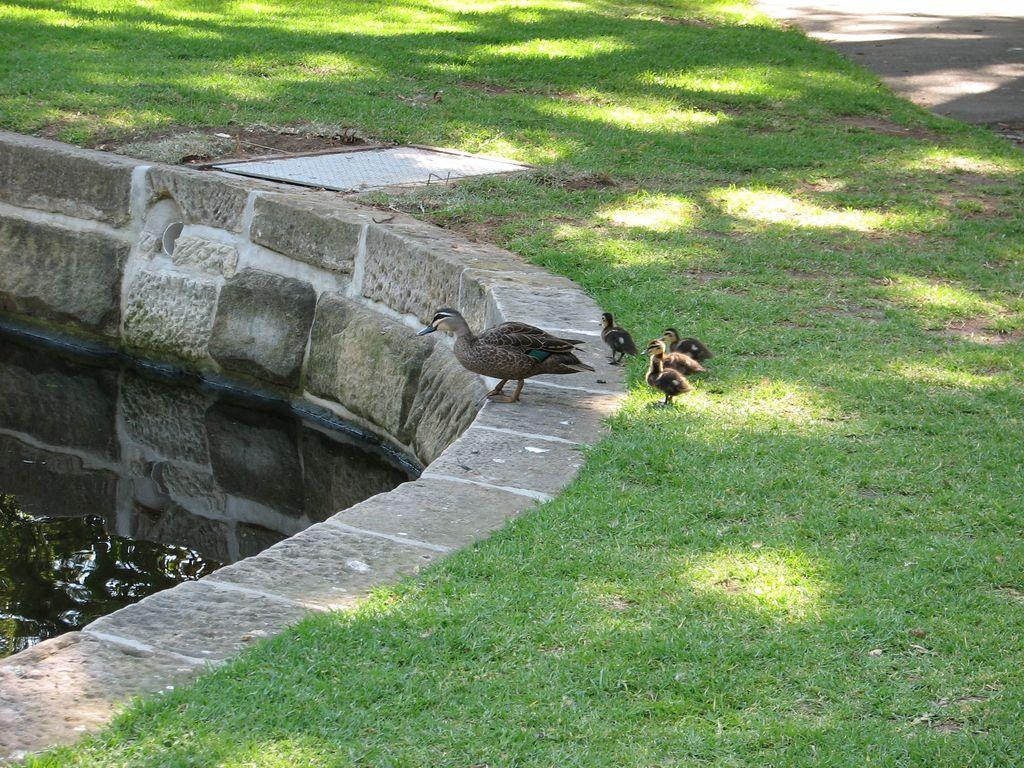What type of body of water is present in the image? There is a pond in the image. What type of bird can be seen in the image? There is a hen in the image. Are there any baby birds in the image? Yes, there are chicks in the image. Where are the hen and chicks located in relation to the pond? The hen and chicks are standing in front of the pond. What type of vegetation is present in the image? There is a lot of grass in the image. What rule is being enforced by the hen in the image? There is no indication in the image that the hen is enforcing any rules. What type of shock can be seen in the image? There is no shock present in the image; it features a hen, chicks, and a pond. 